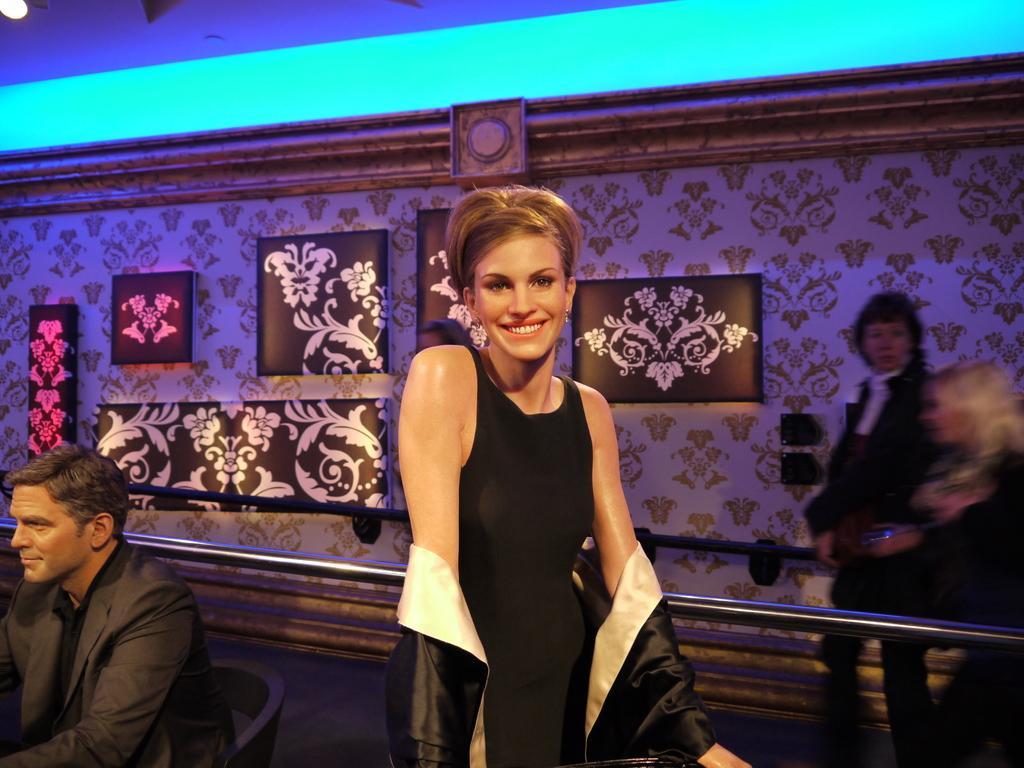How would you summarize this image in a sentence or two? In the image there is a woman, she is standing and posing for the photo she is wearing a black dress and behind the woman there is a man he is sitting on the chair, on the right side there is a wall and there are some painting posters attached to the wall, two people are walking beside the wall and there is a blue light to the roof. 